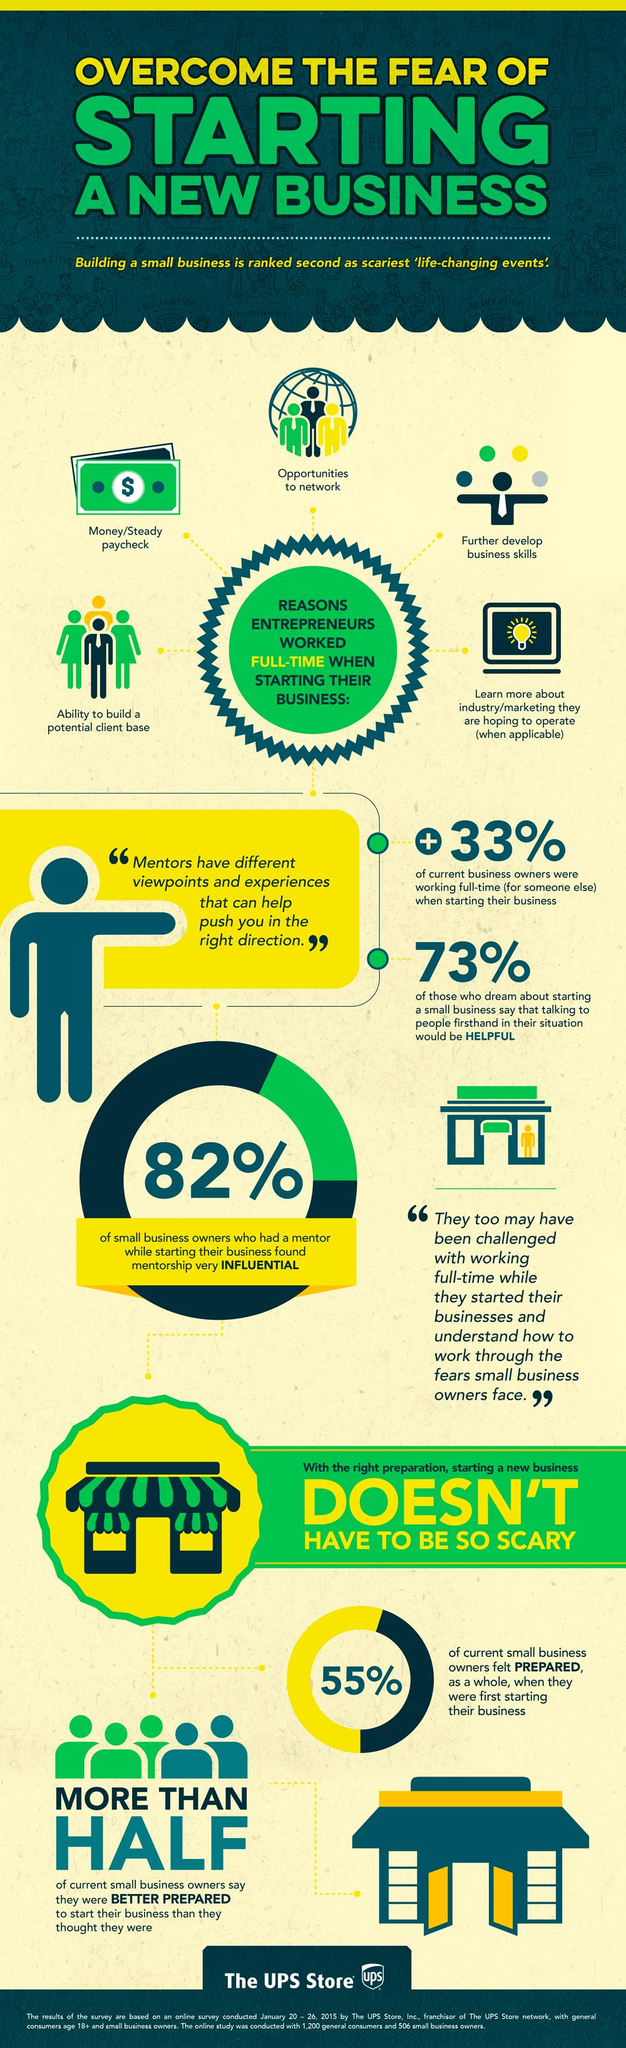List a handful of essential elements in this visual. A significant majority of small business owners, 82%, had a mentor while starting their own business. According to a survey, 33% of current business owners were working full-time when they started their business. 